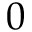<formula> <loc_0><loc_0><loc_500><loc_500>0</formula> 